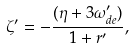<formula> <loc_0><loc_0><loc_500><loc_500>\zeta ^ { \prime } = - \frac { ( \eta + 3 \omega ^ { \prime } _ { d e } ) } { 1 + r ^ { \prime } } ,</formula> 